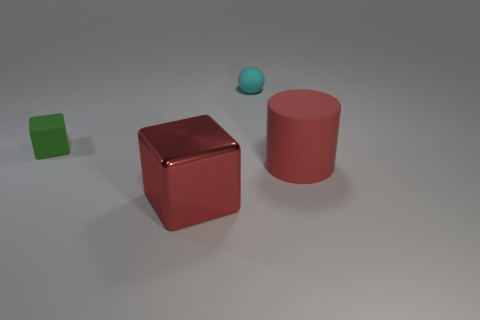What might be the context or setting of this image? The image appears to be a simple 3D render, possibly created to demonstrate basic shapes and colors or for a tutorial in graphic design or modeling. The even lighting and lack of additional elements suggest an instructional or illustrative purpose rather than a depiction of a real-life scene. How could these objects be used to explain the concept of volume in geometry? Each object represents a basic geometric shape—the cube, the cylinder, and the sphere—and can be used to demonstrate how volume is calculated differently for each shape. For example, the volume of the cube is found by cubing the length of one side, the volume of the cylinder is the product of the base area and height, and the volume of a sphere is four-thirds pi times the radius cubed. 